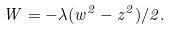<formula> <loc_0><loc_0><loc_500><loc_500>W = - \lambda ( w ^ { 2 } - z ^ { 2 } ) / 2 .</formula> 